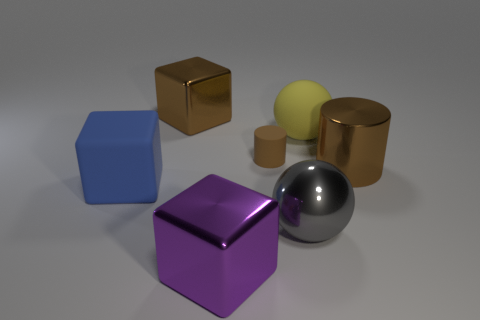Add 3 big cyan matte objects. How many objects exist? 10 Subtract all cubes. How many objects are left? 4 Subtract 0 red cubes. How many objects are left? 7 Subtract all big cylinders. Subtract all shiny cylinders. How many objects are left? 5 Add 2 tiny brown cylinders. How many tiny brown cylinders are left? 3 Add 2 big gray metal things. How many big gray metal things exist? 3 